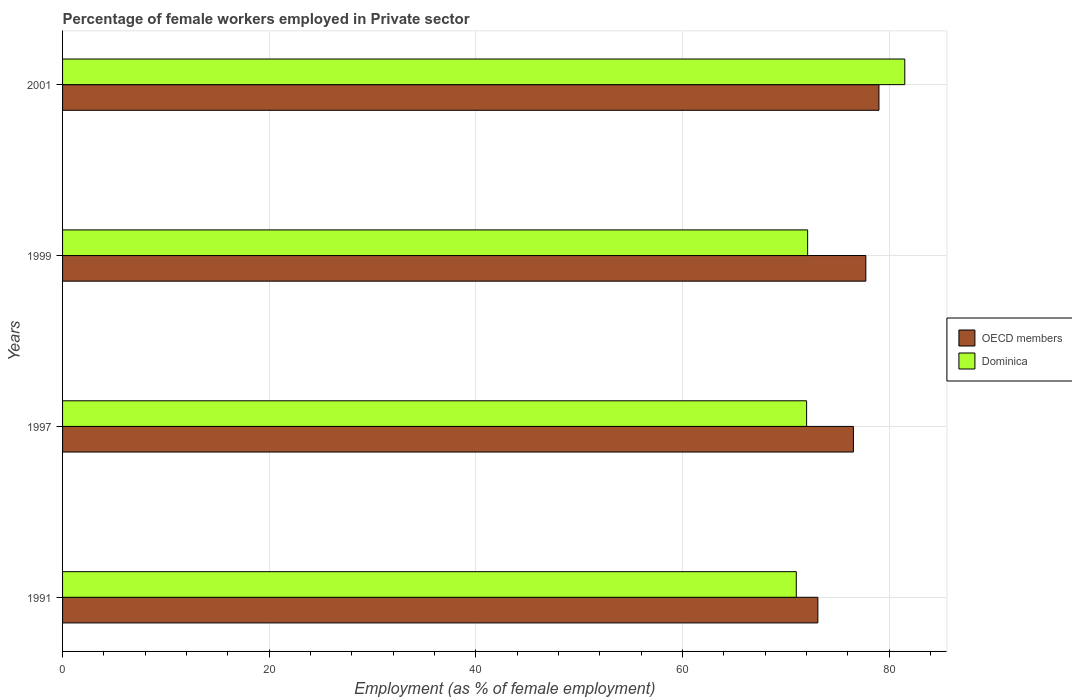How many different coloured bars are there?
Make the answer very short. 2. Are the number of bars per tick equal to the number of legend labels?
Offer a terse response. Yes. How many bars are there on the 3rd tick from the top?
Provide a succinct answer. 2. How many bars are there on the 1st tick from the bottom?
Your answer should be compact. 2. What is the percentage of females employed in Private sector in OECD members in 1999?
Offer a very short reply. 77.73. Across all years, what is the maximum percentage of females employed in Private sector in OECD members?
Your answer should be very brief. 79. Across all years, what is the minimum percentage of females employed in Private sector in Dominica?
Offer a terse response. 71. In which year was the percentage of females employed in Private sector in OECD members maximum?
Keep it short and to the point. 2001. In which year was the percentage of females employed in Private sector in OECD members minimum?
Keep it short and to the point. 1991. What is the total percentage of females employed in Private sector in OECD members in the graph?
Make the answer very short. 306.35. What is the difference between the percentage of females employed in Private sector in Dominica in 1997 and that in 2001?
Your response must be concise. -9.5. What is the difference between the percentage of females employed in Private sector in Dominica in 1997 and the percentage of females employed in Private sector in OECD members in 1999?
Your answer should be compact. -5.73. What is the average percentage of females employed in Private sector in OECD members per year?
Your response must be concise. 76.59. In the year 2001, what is the difference between the percentage of females employed in Private sector in OECD members and percentage of females employed in Private sector in Dominica?
Offer a terse response. -2.5. What is the ratio of the percentage of females employed in Private sector in Dominica in 1997 to that in 2001?
Provide a succinct answer. 0.88. Is the difference between the percentage of females employed in Private sector in OECD members in 1991 and 1997 greater than the difference between the percentage of females employed in Private sector in Dominica in 1991 and 1997?
Provide a succinct answer. No. What is the difference between the highest and the second highest percentage of females employed in Private sector in OECD members?
Your answer should be compact. 1.27. What is the difference between the highest and the lowest percentage of females employed in Private sector in Dominica?
Offer a terse response. 10.5. Is the sum of the percentage of females employed in Private sector in OECD members in 1999 and 2001 greater than the maximum percentage of females employed in Private sector in Dominica across all years?
Provide a short and direct response. Yes. What does the 2nd bar from the bottom in 2001 represents?
Give a very brief answer. Dominica. How many bars are there?
Make the answer very short. 8. How many years are there in the graph?
Offer a terse response. 4. What is the difference between two consecutive major ticks on the X-axis?
Your response must be concise. 20. How are the legend labels stacked?
Provide a short and direct response. Vertical. What is the title of the graph?
Your response must be concise. Percentage of female workers employed in Private sector. Does "Caribbean small states" appear as one of the legend labels in the graph?
Provide a succinct answer. No. What is the label or title of the X-axis?
Your answer should be very brief. Employment (as % of female employment). What is the Employment (as % of female employment) of OECD members in 1991?
Provide a succinct answer. 73.09. What is the Employment (as % of female employment) in OECD members in 1997?
Offer a terse response. 76.53. What is the Employment (as % of female employment) of Dominica in 1997?
Offer a very short reply. 72. What is the Employment (as % of female employment) of OECD members in 1999?
Offer a very short reply. 77.73. What is the Employment (as % of female employment) in Dominica in 1999?
Keep it short and to the point. 72.1. What is the Employment (as % of female employment) in OECD members in 2001?
Your answer should be compact. 79. What is the Employment (as % of female employment) of Dominica in 2001?
Keep it short and to the point. 81.5. Across all years, what is the maximum Employment (as % of female employment) of OECD members?
Give a very brief answer. 79. Across all years, what is the maximum Employment (as % of female employment) in Dominica?
Offer a very short reply. 81.5. Across all years, what is the minimum Employment (as % of female employment) of OECD members?
Your response must be concise. 73.09. What is the total Employment (as % of female employment) of OECD members in the graph?
Ensure brevity in your answer.  306.35. What is the total Employment (as % of female employment) in Dominica in the graph?
Make the answer very short. 296.6. What is the difference between the Employment (as % of female employment) in OECD members in 1991 and that in 1997?
Your answer should be very brief. -3.44. What is the difference between the Employment (as % of female employment) of OECD members in 1991 and that in 1999?
Provide a short and direct response. -4.64. What is the difference between the Employment (as % of female employment) in Dominica in 1991 and that in 1999?
Provide a succinct answer. -1.1. What is the difference between the Employment (as % of female employment) in OECD members in 1991 and that in 2001?
Your answer should be very brief. -5.91. What is the difference between the Employment (as % of female employment) of Dominica in 1991 and that in 2001?
Offer a terse response. -10.5. What is the difference between the Employment (as % of female employment) of OECD members in 1997 and that in 1999?
Your response must be concise. -1.2. What is the difference between the Employment (as % of female employment) in Dominica in 1997 and that in 1999?
Keep it short and to the point. -0.1. What is the difference between the Employment (as % of female employment) in OECD members in 1997 and that in 2001?
Make the answer very short. -2.47. What is the difference between the Employment (as % of female employment) of Dominica in 1997 and that in 2001?
Offer a terse response. -9.5. What is the difference between the Employment (as % of female employment) of OECD members in 1999 and that in 2001?
Provide a succinct answer. -1.27. What is the difference between the Employment (as % of female employment) in Dominica in 1999 and that in 2001?
Your answer should be compact. -9.4. What is the difference between the Employment (as % of female employment) in OECD members in 1991 and the Employment (as % of female employment) in Dominica in 1997?
Offer a very short reply. 1.09. What is the difference between the Employment (as % of female employment) of OECD members in 1991 and the Employment (as % of female employment) of Dominica in 1999?
Your answer should be compact. 0.99. What is the difference between the Employment (as % of female employment) in OECD members in 1991 and the Employment (as % of female employment) in Dominica in 2001?
Provide a short and direct response. -8.41. What is the difference between the Employment (as % of female employment) in OECD members in 1997 and the Employment (as % of female employment) in Dominica in 1999?
Offer a terse response. 4.43. What is the difference between the Employment (as % of female employment) of OECD members in 1997 and the Employment (as % of female employment) of Dominica in 2001?
Make the answer very short. -4.97. What is the difference between the Employment (as % of female employment) in OECD members in 1999 and the Employment (as % of female employment) in Dominica in 2001?
Make the answer very short. -3.77. What is the average Employment (as % of female employment) in OECD members per year?
Your response must be concise. 76.59. What is the average Employment (as % of female employment) of Dominica per year?
Your answer should be very brief. 74.15. In the year 1991, what is the difference between the Employment (as % of female employment) in OECD members and Employment (as % of female employment) in Dominica?
Keep it short and to the point. 2.09. In the year 1997, what is the difference between the Employment (as % of female employment) in OECD members and Employment (as % of female employment) in Dominica?
Give a very brief answer. 4.53. In the year 1999, what is the difference between the Employment (as % of female employment) of OECD members and Employment (as % of female employment) of Dominica?
Offer a terse response. 5.63. In the year 2001, what is the difference between the Employment (as % of female employment) of OECD members and Employment (as % of female employment) of Dominica?
Make the answer very short. -2.5. What is the ratio of the Employment (as % of female employment) in OECD members in 1991 to that in 1997?
Your answer should be compact. 0.96. What is the ratio of the Employment (as % of female employment) of Dominica in 1991 to that in 1997?
Make the answer very short. 0.99. What is the ratio of the Employment (as % of female employment) in OECD members in 1991 to that in 1999?
Provide a short and direct response. 0.94. What is the ratio of the Employment (as % of female employment) in Dominica in 1991 to that in 1999?
Make the answer very short. 0.98. What is the ratio of the Employment (as % of female employment) of OECD members in 1991 to that in 2001?
Your answer should be compact. 0.93. What is the ratio of the Employment (as % of female employment) in Dominica in 1991 to that in 2001?
Your answer should be very brief. 0.87. What is the ratio of the Employment (as % of female employment) in OECD members in 1997 to that in 1999?
Your answer should be compact. 0.98. What is the ratio of the Employment (as % of female employment) in OECD members in 1997 to that in 2001?
Your response must be concise. 0.97. What is the ratio of the Employment (as % of female employment) in Dominica in 1997 to that in 2001?
Keep it short and to the point. 0.88. What is the ratio of the Employment (as % of female employment) in OECD members in 1999 to that in 2001?
Your response must be concise. 0.98. What is the ratio of the Employment (as % of female employment) in Dominica in 1999 to that in 2001?
Make the answer very short. 0.88. What is the difference between the highest and the second highest Employment (as % of female employment) in OECD members?
Give a very brief answer. 1.27. What is the difference between the highest and the lowest Employment (as % of female employment) of OECD members?
Offer a very short reply. 5.91. What is the difference between the highest and the lowest Employment (as % of female employment) in Dominica?
Provide a short and direct response. 10.5. 